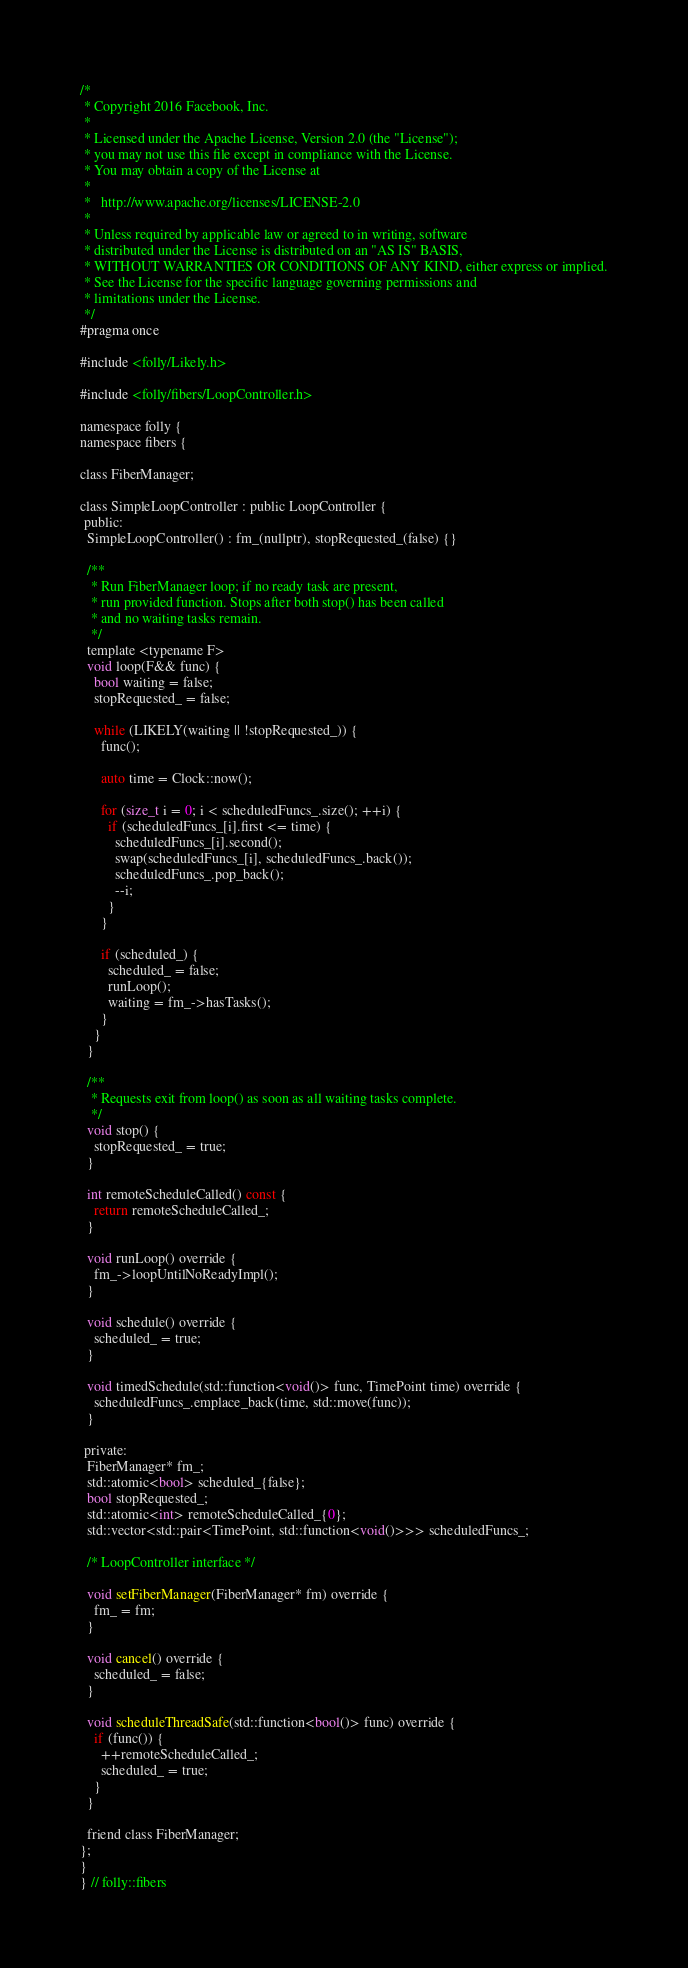Convert code to text. <code><loc_0><loc_0><loc_500><loc_500><_C_>/*
 * Copyright 2016 Facebook, Inc.
 *
 * Licensed under the Apache License, Version 2.0 (the "License");
 * you may not use this file except in compliance with the License.
 * You may obtain a copy of the License at
 *
 *   http://www.apache.org/licenses/LICENSE-2.0
 *
 * Unless required by applicable law or agreed to in writing, software
 * distributed under the License is distributed on an "AS IS" BASIS,
 * WITHOUT WARRANTIES OR CONDITIONS OF ANY KIND, either express or implied.
 * See the License for the specific language governing permissions and
 * limitations under the License.
 */
#pragma once

#include <folly/Likely.h>

#include <folly/fibers/LoopController.h>

namespace folly {
namespace fibers {

class FiberManager;

class SimpleLoopController : public LoopController {
 public:
  SimpleLoopController() : fm_(nullptr), stopRequested_(false) {}

  /**
   * Run FiberManager loop; if no ready task are present,
   * run provided function. Stops after both stop() has been called
   * and no waiting tasks remain.
   */
  template <typename F>
  void loop(F&& func) {
    bool waiting = false;
    stopRequested_ = false;

    while (LIKELY(waiting || !stopRequested_)) {
      func();

      auto time = Clock::now();

      for (size_t i = 0; i < scheduledFuncs_.size(); ++i) {
        if (scheduledFuncs_[i].first <= time) {
          scheduledFuncs_[i].second();
          swap(scheduledFuncs_[i], scheduledFuncs_.back());
          scheduledFuncs_.pop_back();
          --i;
        }
      }

      if (scheduled_) {
        scheduled_ = false;
        runLoop();
        waiting = fm_->hasTasks();
      }
    }
  }

  /**
   * Requests exit from loop() as soon as all waiting tasks complete.
   */
  void stop() {
    stopRequested_ = true;
  }

  int remoteScheduleCalled() const {
    return remoteScheduleCalled_;
  }

  void runLoop() override {
    fm_->loopUntilNoReadyImpl();
  }

  void schedule() override {
    scheduled_ = true;
  }

  void timedSchedule(std::function<void()> func, TimePoint time) override {
    scheduledFuncs_.emplace_back(time, std::move(func));
  }

 private:
  FiberManager* fm_;
  std::atomic<bool> scheduled_{false};
  bool stopRequested_;
  std::atomic<int> remoteScheduleCalled_{0};
  std::vector<std::pair<TimePoint, std::function<void()>>> scheduledFuncs_;

  /* LoopController interface */

  void setFiberManager(FiberManager* fm) override {
    fm_ = fm;
  }

  void cancel() override {
    scheduled_ = false;
  }

  void scheduleThreadSafe(std::function<bool()> func) override {
    if (func()) {
      ++remoteScheduleCalled_;
      scheduled_ = true;
    }
  }

  friend class FiberManager;
};
}
} // folly::fibers
</code> 